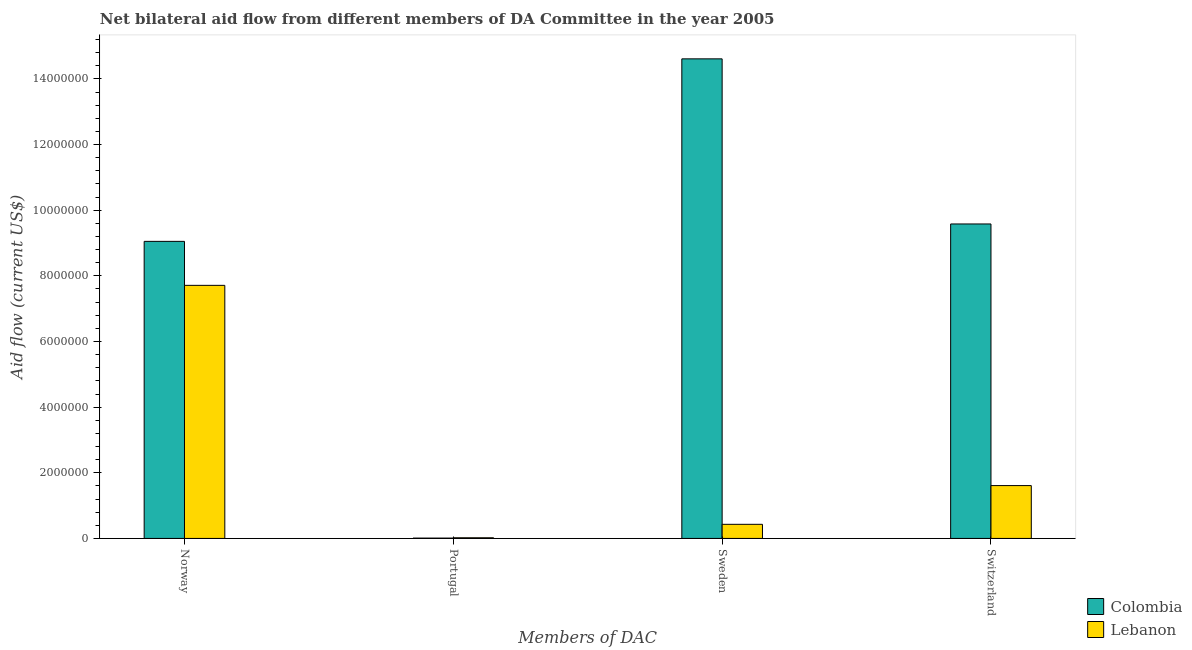How many groups of bars are there?
Provide a succinct answer. 4. Are the number of bars on each tick of the X-axis equal?
Provide a succinct answer. Yes. What is the label of the 4th group of bars from the left?
Keep it short and to the point. Switzerland. What is the amount of aid given by norway in Colombia?
Offer a terse response. 9.05e+06. Across all countries, what is the maximum amount of aid given by norway?
Provide a short and direct response. 9.05e+06. Across all countries, what is the minimum amount of aid given by norway?
Your response must be concise. 7.71e+06. In which country was the amount of aid given by portugal maximum?
Your response must be concise. Lebanon. In which country was the amount of aid given by portugal minimum?
Ensure brevity in your answer.  Colombia. What is the total amount of aid given by portugal in the graph?
Your answer should be compact. 3.00e+04. What is the difference between the amount of aid given by sweden in Lebanon and that in Colombia?
Keep it short and to the point. -1.42e+07. What is the difference between the amount of aid given by switzerland in Lebanon and the amount of aid given by portugal in Colombia?
Offer a very short reply. 1.60e+06. What is the average amount of aid given by switzerland per country?
Provide a short and direct response. 5.60e+06. What is the difference between the amount of aid given by switzerland and amount of aid given by norway in Colombia?
Ensure brevity in your answer.  5.30e+05. In how many countries, is the amount of aid given by norway greater than 4000000 US$?
Offer a very short reply. 2. What is the ratio of the amount of aid given by norway in Colombia to that in Lebanon?
Offer a terse response. 1.17. Is the difference between the amount of aid given by sweden in Colombia and Lebanon greater than the difference between the amount of aid given by norway in Colombia and Lebanon?
Your response must be concise. Yes. What is the difference between the highest and the second highest amount of aid given by sweden?
Provide a short and direct response. 1.42e+07. What is the difference between the highest and the lowest amount of aid given by sweden?
Ensure brevity in your answer.  1.42e+07. In how many countries, is the amount of aid given by sweden greater than the average amount of aid given by sweden taken over all countries?
Your answer should be compact. 1. Is the sum of the amount of aid given by sweden in Lebanon and Colombia greater than the maximum amount of aid given by norway across all countries?
Give a very brief answer. Yes. What does the 2nd bar from the right in Portugal represents?
Make the answer very short. Colombia. Is it the case that in every country, the sum of the amount of aid given by norway and amount of aid given by portugal is greater than the amount of aid given by sweden?
Your answer should be very brief. No. Are all the bars in the graph horizontal?
Make the answer very short. No. What is the difference between two consecutive major ticks on the Y-axis?
Offer a terse response. 2.00e+06. What is the title of the graph?
Give a very brief answer. Net bilateral aid flow from different members of DA Committee in the year 2005. Does "Tonga" appear as one of the legend labels in the graph?
Provide a short and direct response. No. What is the label or title of the X-axis?
Give a very brief answer. Members of DAC. What is the Aid flow (current US$) in Colombia in Norway?
Give a very brief answer. 9.05e+06. What is the Aid flow (current US$) of Lebanon in Norway?
Give a very brief answer. 7.71e+06. What is the Aid flow (current US$) in Colombia in Portugal?
Your response must be concise. 10000. What is the Aid flow (current US$) in Lebanon in Portugal?
Keep it short and to the point. 2.00e+04. What is the Aid flow (current US$) of Colombia in Sweden?
Ensure brevity in your answer.  1.46e+07. What is the Aid flow (current US$) of Lebanon in Sweden?
Provide a succinct answer. 4.30e+05. What is the Aid flow (current US$) in Colombia in Switzerland?
Keep it short and to the point. 9.58e+06. What is the Aid flow (current US$) in Lebanon in Switzerland?
Ensure brevity in your answer.  1.61e+06. Across all Members of DAC, what is the maximum Aid flow (current US$) in Colombia?
Provide a short and direct response. 1.46e+07. Across all Members of DAC, what is the maximum Aid flow (current US$) of Lebanon?
Your answer should be very brief. 7.71e+06. What is the total Aid flow (current US$) in Colombia in the graph?
Your answer should be very brief. 3.32e+07. What is the total Aid flow (current US$) of Lebanon in the graph?
Offer a very short reply. 9.77e+06. What is the difference between the Aid flow (current US$) in Colombia in Norway and that in Portugal?
Your answer should be compact. 9.04e+06. What is the difference between the Aid flow (current US$) in Lebanon in Norway and that in Portugal?
Offer a very short reply. 7.69e+06. What is the difference between the Aid flow (current US$) in Colombia in Norway and that in Sweden?
Your response must be concise. -5.56e+06. What is the difference between the Aid flow (current US$) in Lebanon in Norway and that in Sweden?
Ensure brevity in your answer.  7.28e+06. What is the difference between the Aid flow (current US$) in Colombia in Norway and that in Switzerland?
Your answer should be compact. -5.30e+05. What is the difference between the Aid flow (current US$) of Lebanon in Norway and that in Switzerland?
Provide a succinct answer. 6.10e+06. What is the difference between the Aid flow (current US$) of Colombia in Portugal and that in Sweden?
Make the answer very short. -1.46e+07. What is the difference between the Aid flow (current US$) in Lebanon in Portugal and that in Sweden?
Give a very brief answer. -4.10e+05. What is the difference between the Aid flow (current US$) in Colombia in Portugal and that in Switzerland?
Offer a terse response. -9.57e+06. What is the difference between the Aid flow (current US$) in Lebanon in Portugal and that in Switzerland?
Give a very brief answer. -1.59e+06. What is the difference between the Aid flow (current US$) of Colombia in Sweden and that in Switzerland?
Your response must be concise. 5.03e+06. What is the difference between the Aid flow (current US$) in Lebanon in Sweden and that in Switzerland?
Your answer should be very brief. -1.18e+06. What is the difference between the Aid flow (current US$) of Colombia in Norway and the Aid flow (current US$) of Lebanon in Portugal?
Give a very brief answer. 9.03e+06. What is the difference between the Aid flow (current US$) of Colombia in Norway and the Aid flow (current US$) of Lebanon in Sweden?
Make the answer very short. 8.62e+06. What is the difference between the Aid flow (current US$) of Colombia in Norway and the Aid flow (current US$) of Lebanon in Switzerland?
Keep it short and to the point. 7.44e+06. What is the difference between the Aid flow (current US$) in Colombia in Portugal and the Aid flow (current US$) in Lebanon in Sweden?
Offer a very short reply. -4.20e+05. What is the difference between the Aid flow (current US$) of Colombia in Portugal and the Aid flow (current US$) of Lebanon in Switzerland?
Offer a terse response. -1.60e+06. What is the difference between the Aid flow (current US$) of Colombia in Sweden and the Aid flow (current US$) of Lebanon in Switzerland?
Offer a terse response. 1.30e+07. What is the average Aid flow (current US$) in Colombia per Members of DAC?
Your response must be concise. 8.31e+06. What is the average Aid flow (current US$) in Lebanon per Members of DAC?
Ensure brevity in your answer.  2.44e+06. What is the difference between the Aid flow (current US$) in Colombia and Aid flow (current US$) in Lebanon in Norway?
Provide a short and direct response. 1.34e+06. What is the difference between the Aid flow (current US$) in Colombia and Aid flow (current US$) in Lebanon in Sweden?
Offer a terse response. 1.42e+07. What is the difference between the Aid flow (current US$) of Colombia and Aid flow (current US$) of Lebanon in Switzerland?
Give a very brief answer. 7.97e+06. What is the ratio of the Aid flow (current US$) in Colombia in Norway to that in Portugal?
Provide a short and direct response. 905. What is the ratio of the Aid flow (current US$) of Lebanon in Norway to that in Portugal?
Keep it short and to the point. 385.5. What is the ratio of the Aid flow (current US$) of Colombia in Norway to that in Sweden?
Your response must be concise. 0.62. What is the ratio of the Aid flow (current US$) in Lebanon in Norway to that in Sweden?
Keep it short and to the point. 17.93. What is the ratio of the Aid flow (current US$) in Colombia in Norway to that in Switzerland?
Offer a terse response. 0.94. What is the ratio of the Aid flow (current US$) of Lebanon in Norway to that in Switzerland?
Give a very brief answer. 4.79. What is the ratio of the Aid flow (current US$) of Colombia in Portugal to that in Sweden?
Your answer should be compact. 0. What is the ratio of the Aid flow (current US$) of Lebanon in Portugal to that in Sweden?
Give a very brief answer. 0.05. What is the ratio of the Aid flow (current US$) in Lebanon in Portugal to that in Switzerland?
Your response must be concise. 0.01. What is the ratio of the Aid flow (current US$) of Colombia in Sweden to that in Switzerland?
Ensure brevity in your answer.  1.53. What is the ratio of the Aid flow (current US$) in Lebanon in Sweden to that in Switzerland?
Offer a terse response. 0.27. What is the difference between the highest and the second highest Aid flow (current US$) of Colombia?
Offer a terse response. 5.03e+06. What is the difference between the highest and the second highest Aid flow (current US$) in Lebanon?
Your response must be concise. 6.10e+06. What is the difference between the highest and the lowest Aid flow (current US$) in Colombia?
Make the answer very short. 1.46e+07. What is the difference between the highest and the lowest Aid flow (current US$) in Lebanon?
Offer a very short reply. 7.69e+06. 